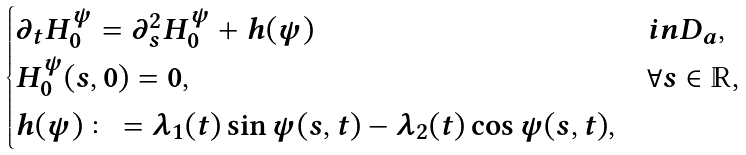<formula> <loc_0><loc_0><loc_500><loc_500>\begin{cases} \partial _ { t } H ^ { \psi } _ { 0 } = \partial _ { s } ^ { 2 } H ^ { \psi } _ { 0 } + h ( \psi ) & i n D _ { a } , \\ H ^ { \psi } _ { 0 } ( s , 0 ) = 0 , & \forall s \in \mathbb { R } , \\ h ( \psi ) \colon = \lambda _ { 1 } ( t ) \sin \psi ( s , t ) - \lambda _ { 2 } ( t ) \cos \psi ( s , t ) , \end{cases}</formula> 